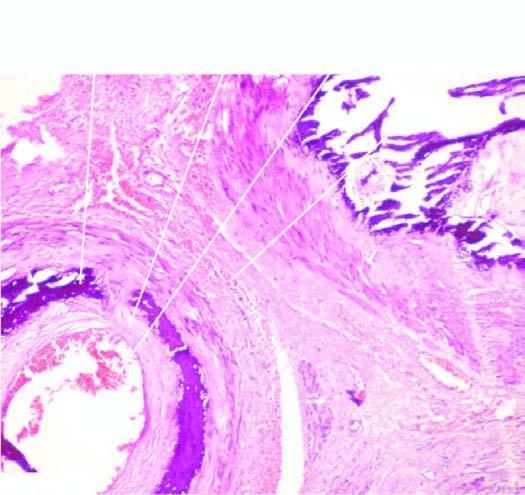s there calcification exclusively in the tunica media unassociated with any significant inflammation?
Answer the question using a single word or phrase. Yes 